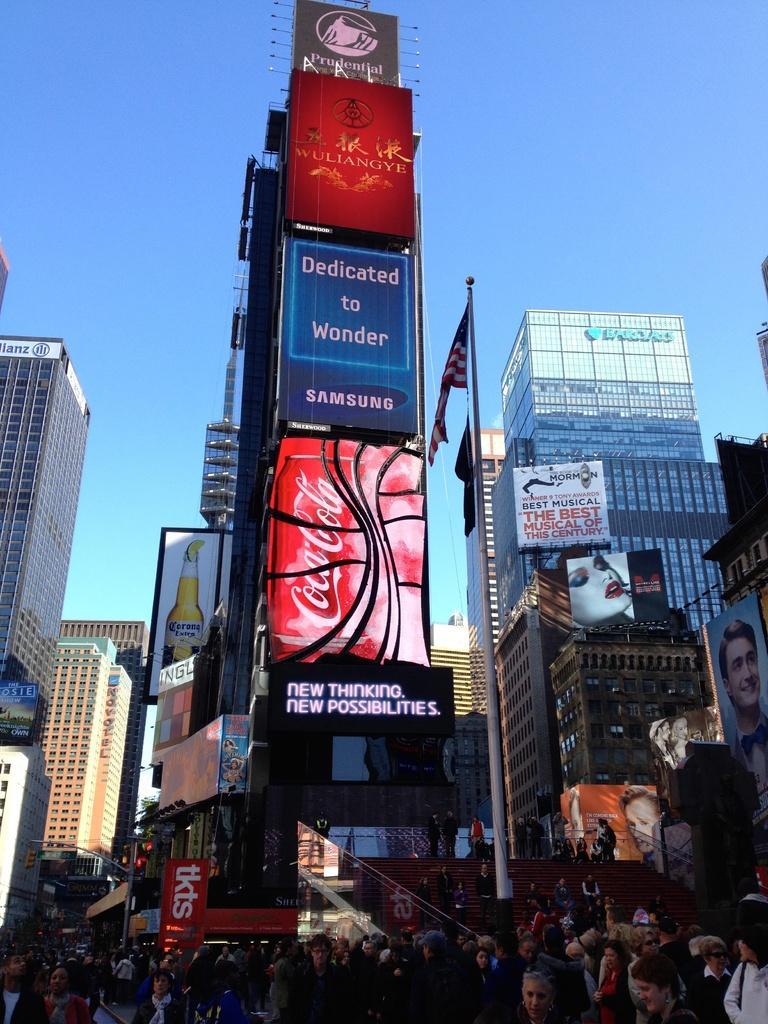In one or two sentences, can you explain what this image depicts? In this image there is the sky towards the top of the image, there are buildings, there are boards, there is text on the boards, there is a pole, there is a flag, there are group of persons in the bottom of the image. 